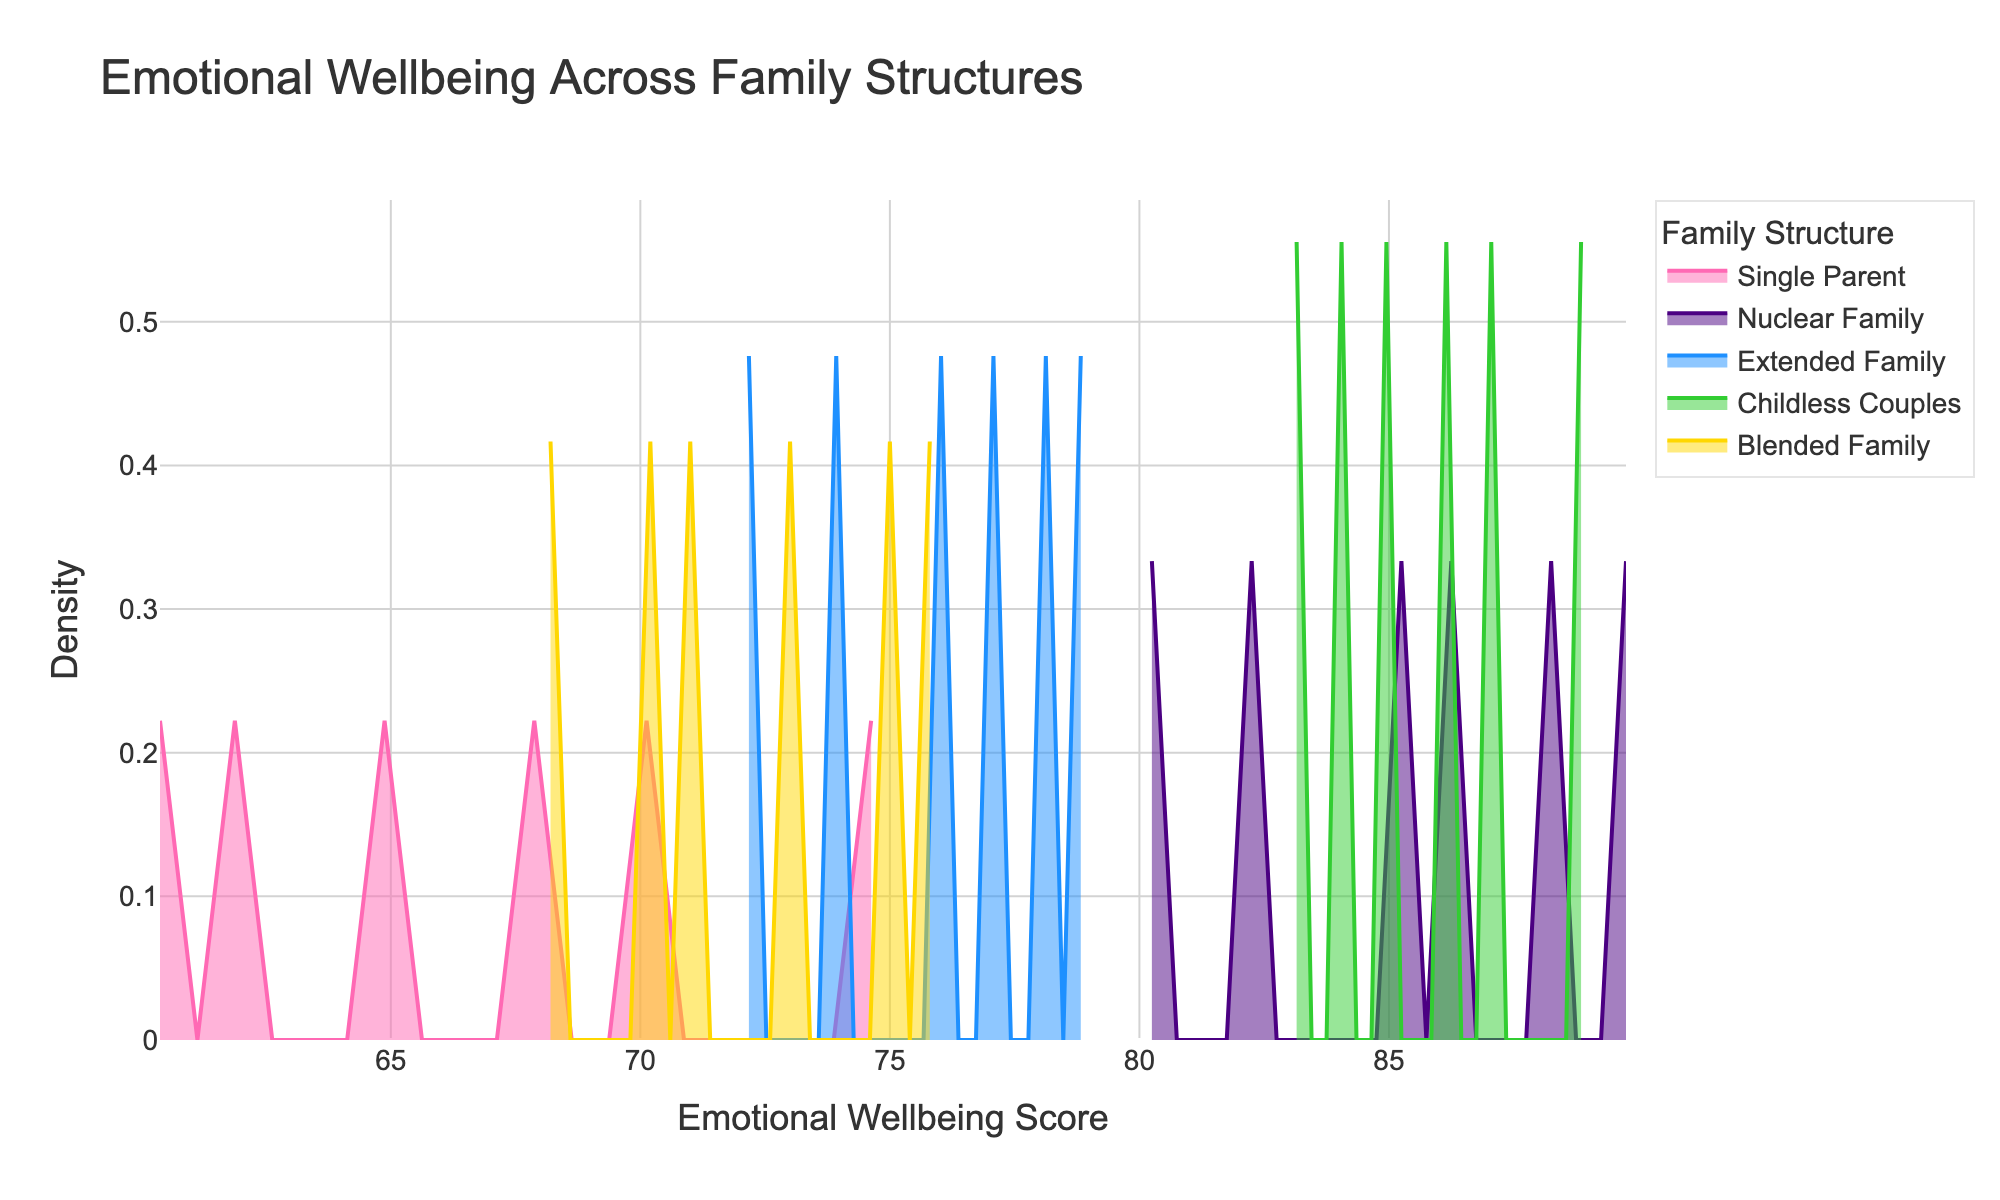What is the title of the plot? To determine the title, you simply look at the top of the plot where the title is usually positioned.
Answer: Emotional Wellbeing Across Family Structures Which family structure has the highest peak density value? Looking at the y-axis peaks for each line, you compare the highest points of each family structure.
Answer: Nuclear Family What is the range of Emotional Wellbeing Scores shown on the x-axis? The x-axis represents the range of Emotional Wellbeing Scores, and looking at the start and end points tells you the range.
Answer: 60 to 90 Which family structure seems to have the broadest spread of Emotional Wellbeing Scores? To determine the broadest spread, observe which density plot spans the widest range on the x-axis.
Answer: Single Parent How does the peak density of Blended Families compare to Childless Couples? Compare the highest points of the density lines for Blended Families and Childless Couples.
Answer: Blended Families have a lower peak than Childless Couples Which family structure has the least peak density value? By looking at all the peak values on the y-axis, identify the smallest peak.
Answer: Single Parent What is the approximate Emotional Wellbeing Score corresponding to the peak density of Childless Couples? Locate the highest point in the density plot for Childless Couples and find the corresponding x-axis value.
Answer: Around 85 Are there any family structures with overlapping density peaks? Look at the density plots and see if any of the peaks are at the same Emotional Wellbeing Score.
Answer: No Between Extended Families and Nuclear Families, which one has a higher peak density value? Compare the highest points of the density lines for Extended Families and Nuclear Families.
Answer: Nuclear Families What is the Emotional Wellbeing Score range with the highest density for Nuclear Families? Look at the section of the x-axis where Nuclear Families have the highest density values.
Answer: 85-90 